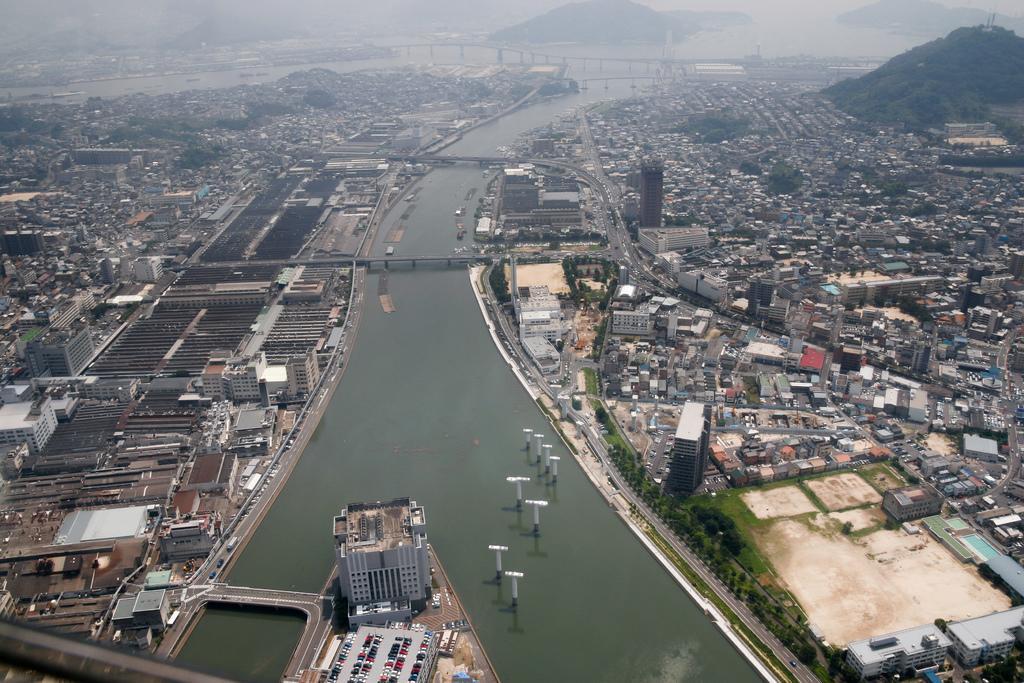How would you summarize this image in a sentence or two? In this image we can see a group of buildings, houses, trees, roads, some poles and a water body under the bridges. On the backside we can see a group of trees on the hills. 